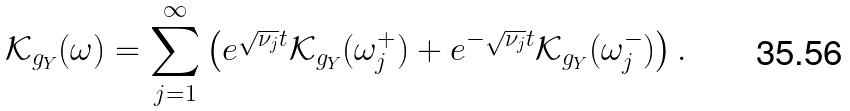Convert formula to latex. <formula><loc_0><loc_0><loc_500><loc_500>\mathcal { K } _ { g _ { Y } } ( \omega ) = \sum _ { j = 1 } ^ { \infty } \left ( e ^ { \sqrt { \nu _ { j } } t } \mathcal { K } _ { g _ { Y } } ( \omega ^ { + } _ { j } ) + e ^ { - \sqrt { \nu _ { j } } t } \mathcal { K } _ { g _ { Y } } ( \omega ^ { - } _ { j } ) \right ) .</formula> 